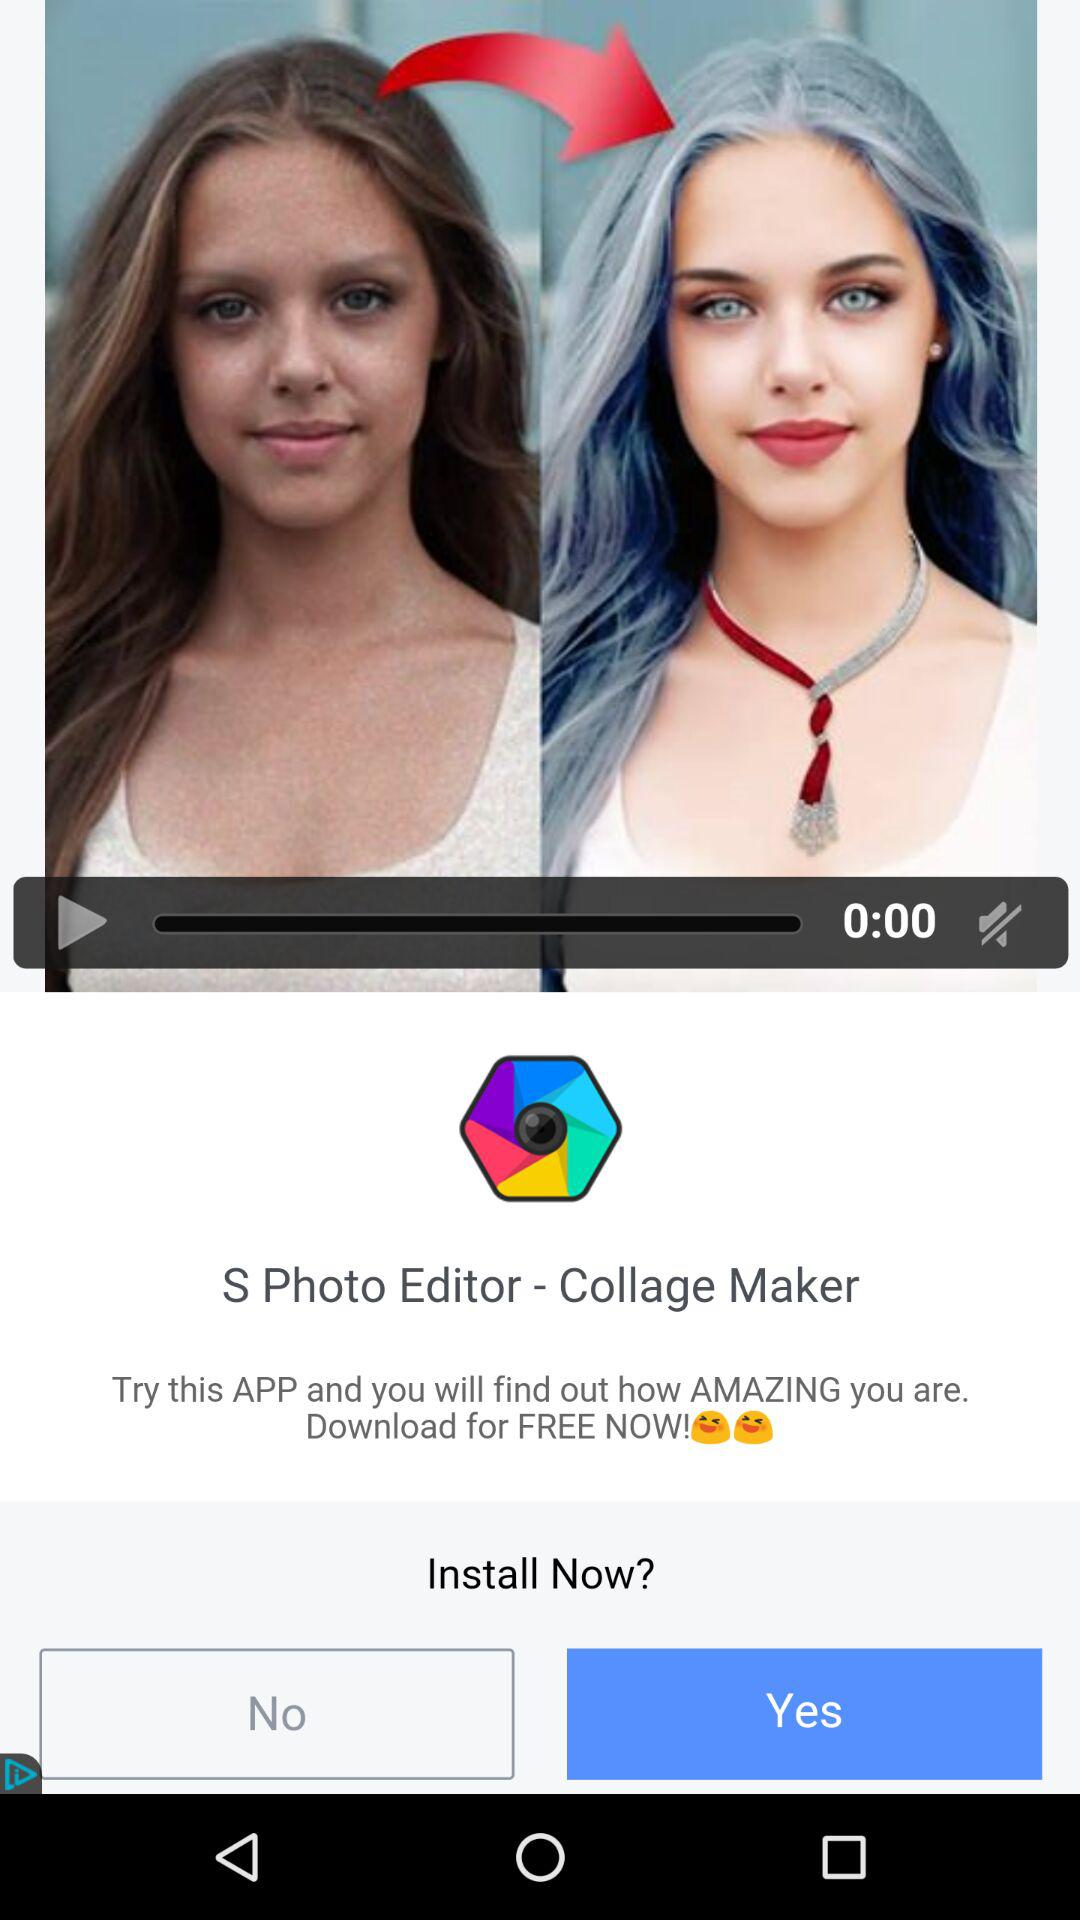How many happy faces are on the screen?
Answer the question using a single word or phrase. 2 